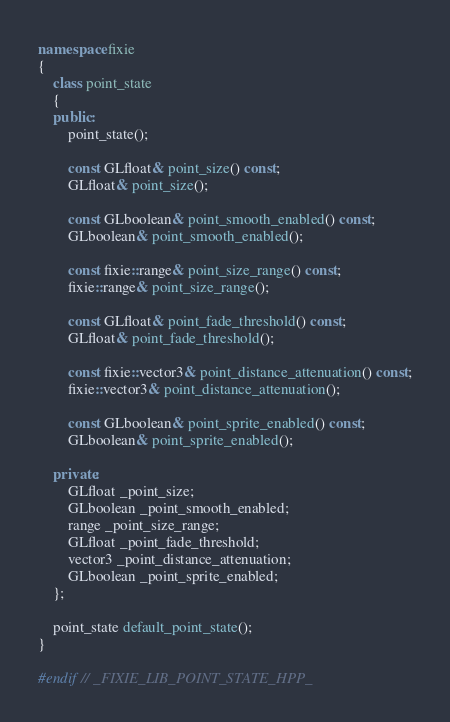<code> <loc_0><loc_0><loc_500><loc_500><_C++_>namespace fixie
{
    class point_state
    {
    public:
        point_state();

        const GLfloat& point_size() const;
        GLfloat& point_size();

        const GLboolean& point_smooth_enabled() const;
        GLboolean& point_smooth_enabled();

        const fixie::range& point_size_range() const;
        fixie::range& point_size_range();

        const GLfloat& point_fade_threshold() const;
        GLfloat& point_fade_threshold();

        const fixie::vector3& point_distance_attenuation() const;
        fixie::vector3& point_distance_attenuation();

        const GLboolean& point_sprite_enabled() const;
        GLboolean& point_sprite_enabled();

    private:
        GLfloat _point_size;
        GLboolean _point_smooth_enabled;
        range _point_size_range;
        GLfloat _point_fade_threshold;
        vector3 _point_distance_attenuation;
        GLboolean _point_sprite_enabled;
    };

    point_state default_point_state();
}

#endif // _FIXIE_LIB_POINT_STATE_HPP_
</code> 